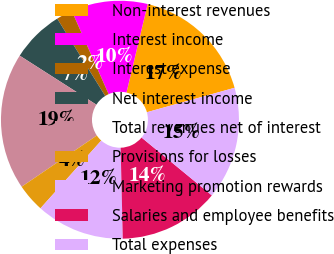Convert chart. <chart><loc_0><loc_0><loc_500><loc_500><pie_chart><fcel>Non-interest revenues<fcel>Interest income<fcel>Interest expense<fcel>Net interest income<fcel>Total revenues net of interest<fcel>Provisions for losses<fcel>Marketing promotion rewards<fcel>Salaries and employee benefits<fcel>Total expenses<nl><fcel>16.93%<fcel>10.38%<fcel>2.2%<fcel>7.11%<fcel>18.57%<fcel>3.84%<fcel>12.02%<fcel>13.66%<fcel>15.29%<nl></chart> 